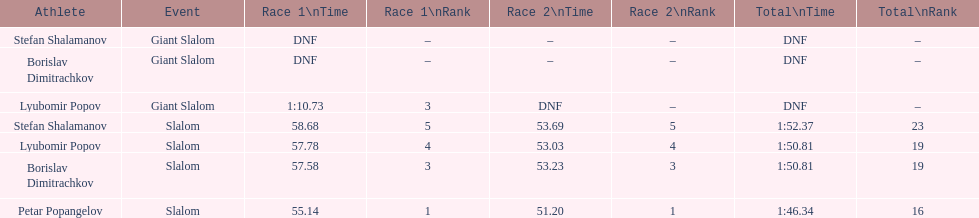How long did it take for lyubomir popov to finish the giant slalom in race 1? 1:10.73. 